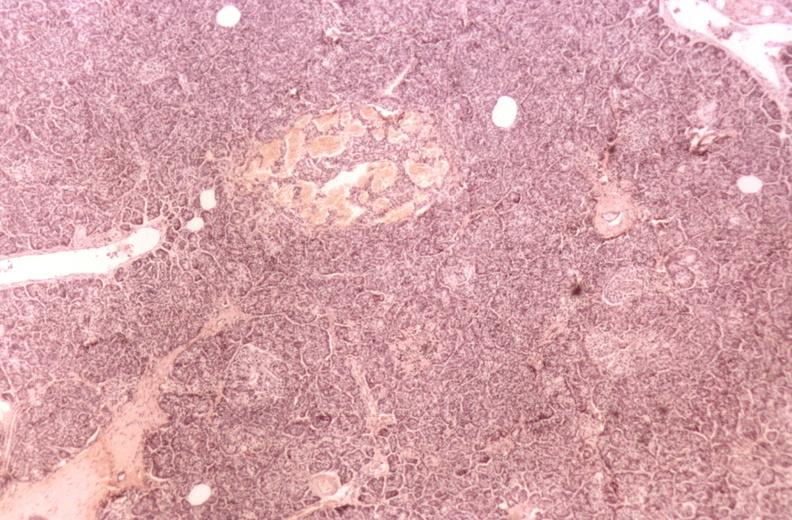what is present?
Answer the question using a single word or phrase. Pancreas 